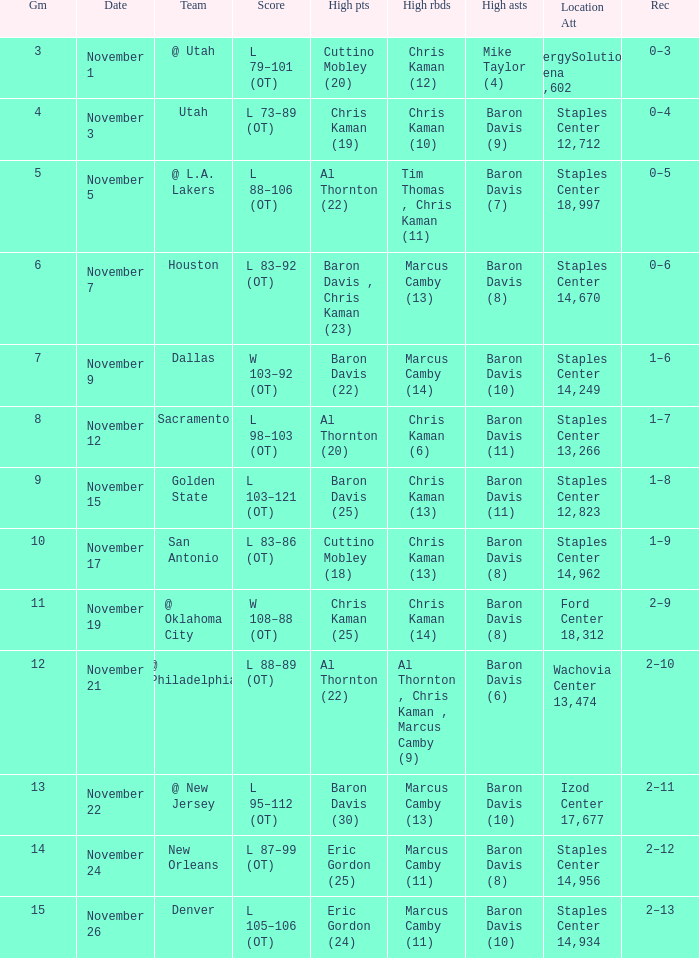Name the total number of score for staples center 13,266 1.0. 